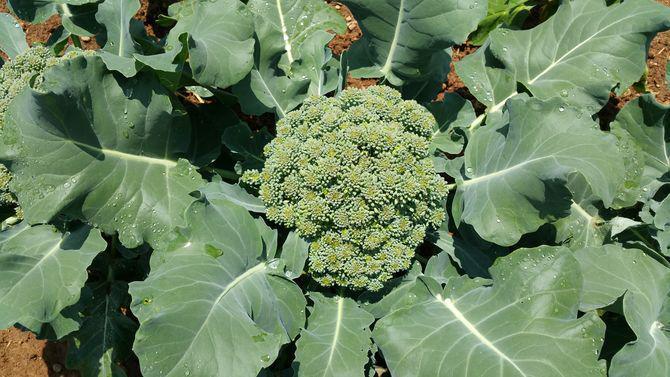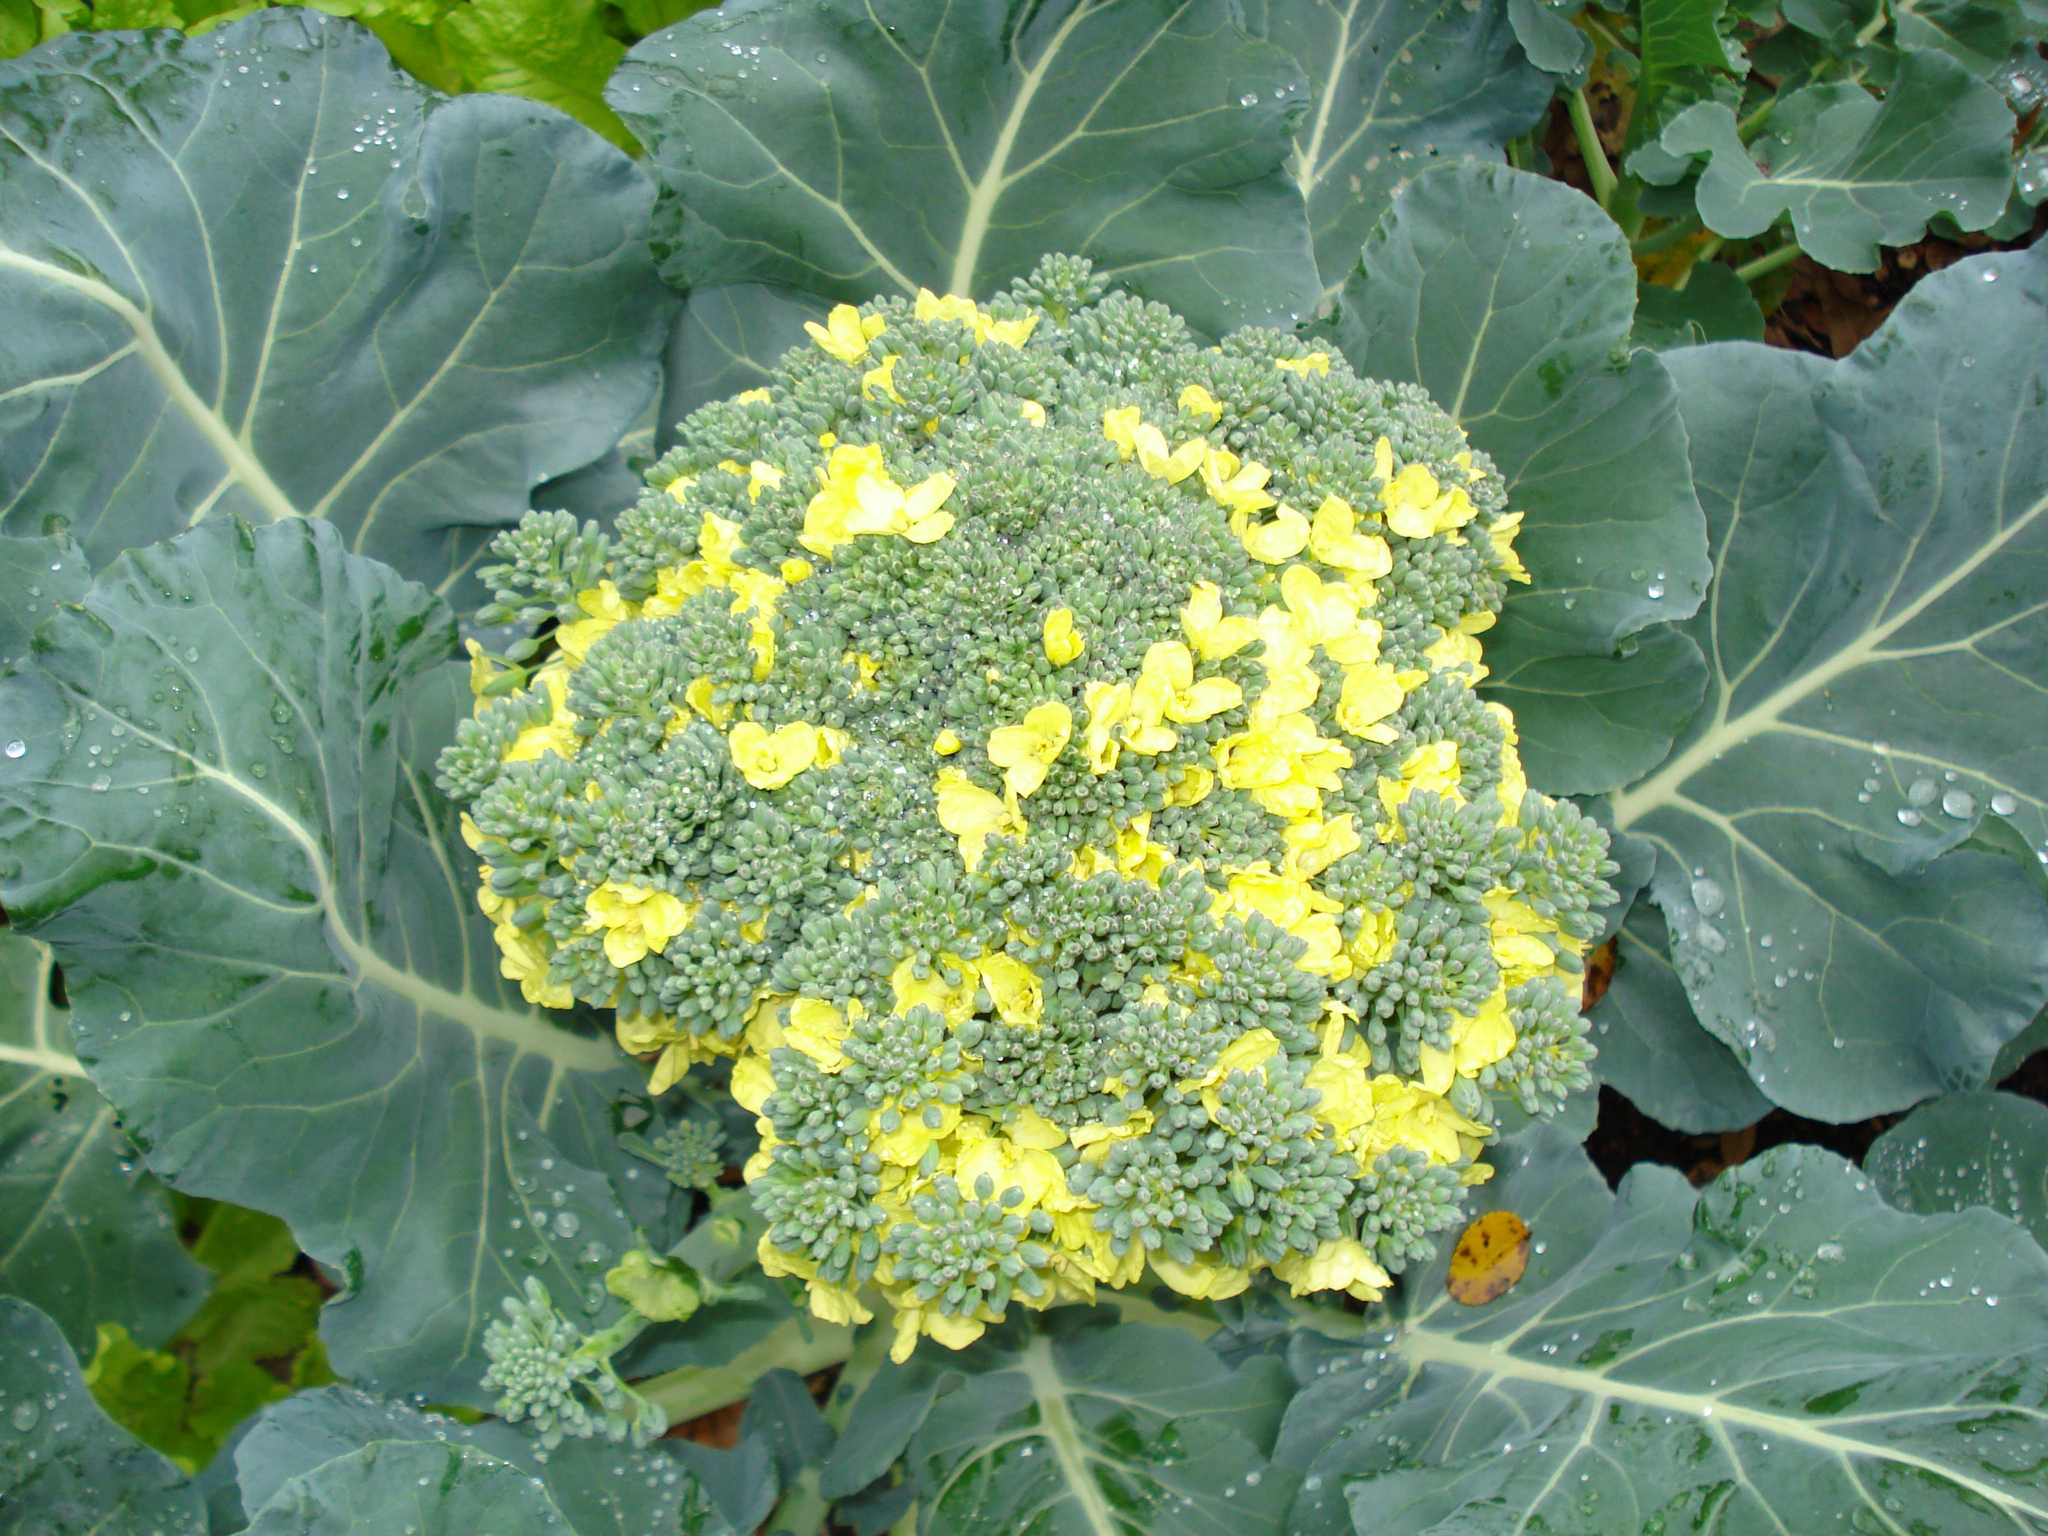The first image is the image on the left, the second image is the image on the right. Considering the images on both sides, is "The plants are entirely green." valid? Answer yes or no. No. The first image is the image on the left, the second image is the image on the right. Considering the images on both sides, is "The left and right image contains the same number of growing broccoli with at least one flowering." valid? Answer yes or no. Yes. 